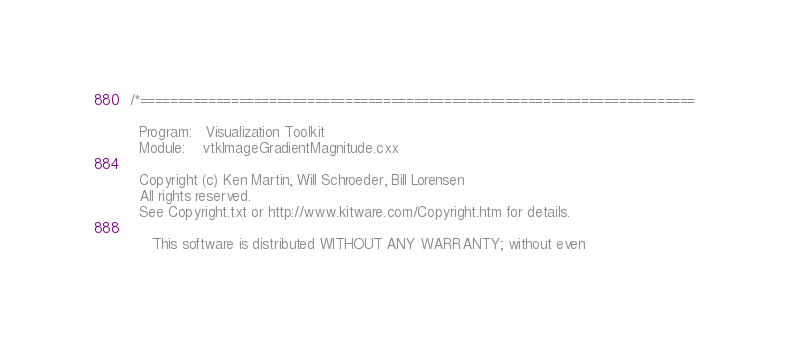<code> <loc_0><loc_0><loc_500><loc_500><_C++_>/*=========================================================================

  Program:   Visualization Toolkit
  Module:    vtkImageGradientMagnitude.cxx

  Copyright (c) Ken Martin, Will Schroeder, Bill Lorensen
  All rights reserved.
  See Copyright.txt or http://www.kitware.com/Copyright.htm for details.

     This software is distributed WITHOUT ANY WARRANTY; without even</code> 